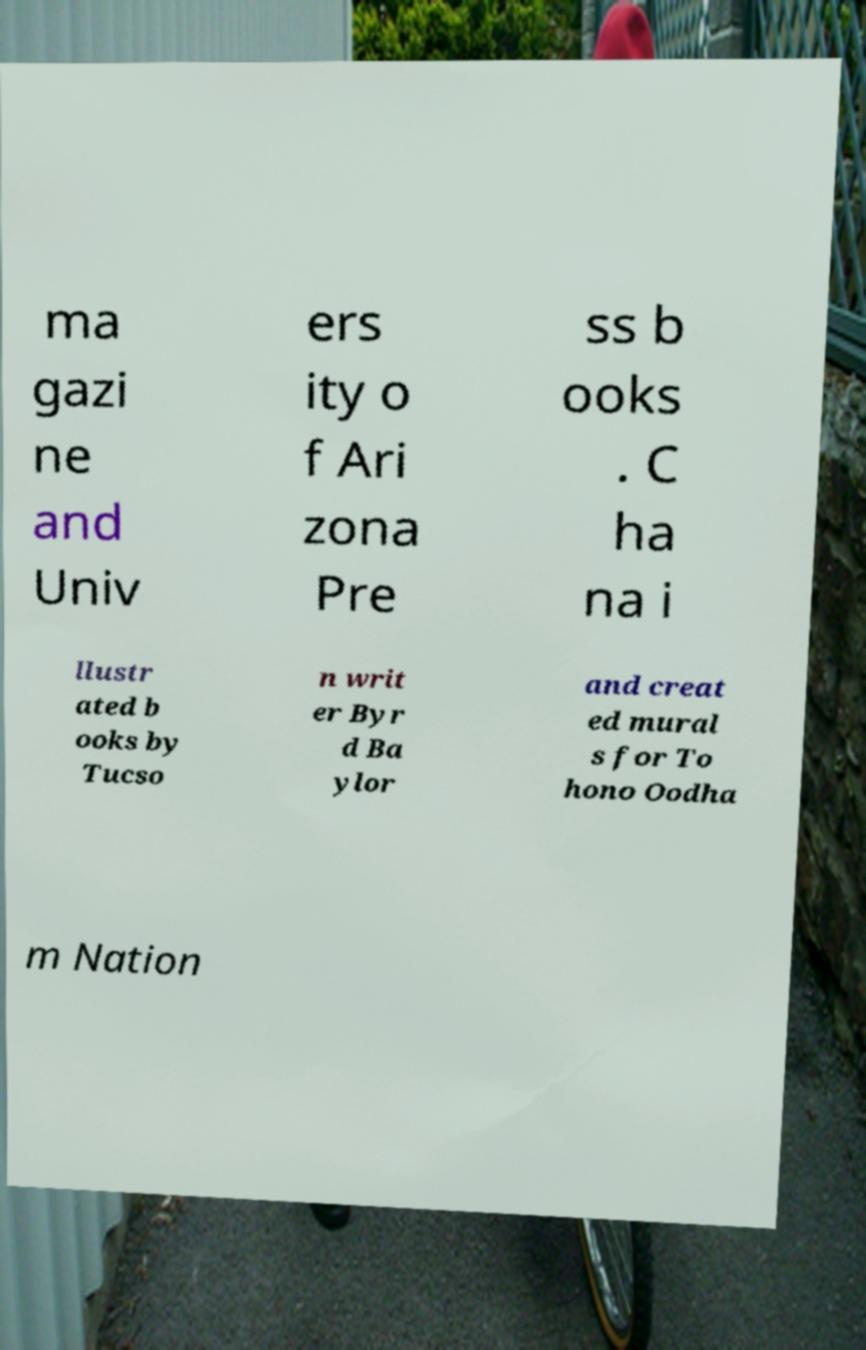For documentation purposes, I need the text within this image transcribed. Could you provide that? ma gazi ne and Univ ers ity o f Ari zona Pre ss b ooks . C ha na i llustr ated b ooks by Tucso n writ er Byr d Ba ylor and creat ed mural s for To hono Oodha m Nation 